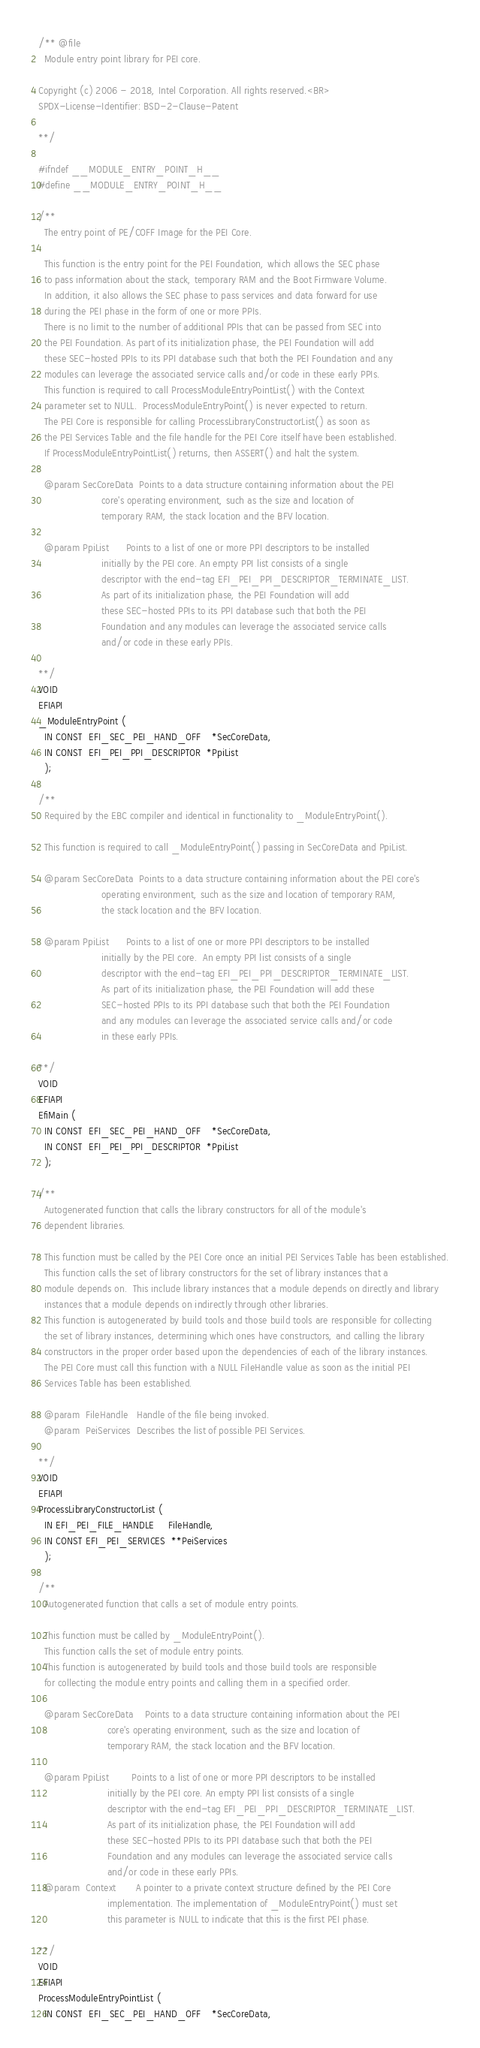<code> <loc_0><loc_0><loc_500><loc_500><_C_>/** @file
  Module entry point library for PEI core.

Copyright (c) 2006 - 2018, Intel Corporation. All rights reserved.<BR>
SPDX-License-Identifier: BSD-2-Clause-Patent

**/

#ifndef __MODULE_ENTRY_POINT_H__
#define __MODULE_ENTRY_POINT_H__

/**
  The entry point of PE/COFF Image for the PEI Core.

  This function is the entry point for the PEI Foundation, which allows the SEC phase
  to pass information about the stack, temporary RAM and the Boot Firmware Volume.
  In addition, it also allows the SEC phase to pass services and data forward for use
  during the PEI phase in the form of one or more PPIs.
  There is no limit to the number of additional PPIs that can be passed from SEC into
  the PEI Foundation. As part of its initialization phase, the PEI Foundation will add
  these SEC-hosted PPIs to its PPI database such that both the PEI Foundation and any
  modules can leverage the associated service calls and/or code in these early PPIs.
  This function is required to call ProcessModuleEntryPointList() with the Context
  parameter set to NULL.  ProcessModuleEntryPoint() is never expected to return.
  The PEI Core is responsible for calling ProcessLibraryConstructorList() as soon as
  the PEI Services Table and the file handle for the PEI Core itself have been established.
  If ProcessModuleEntryPointList() returns, then ASSERT() and halt the system.

  @param SecCoreData  Points to a data structure containing information about the PEI
                      core's operating environment, such as the size and location of
                      temporary RAM, the stack location and the BFV location.

  @param PpiList      Points to a list of one or more PPI descriptors to be installed
                      initially by the PEI core. An empty PPI list consists of a single
                      descriptor with the end-tag EFI_PEI_PPI_DESCRIPTOR_TERMINATE_LIST.
                      As part of its initialization phase, the PEI Foundation will add
                      these SEC-hosted PPIs to its PPI database such that both the PEI
                      Foundation and any modules can leverage the associated service calls
                      and/or code in these early PPIs.

**/
VOID
EFIAPI
_ModuleEntryPoint (
  IN CONST  EFI_SEC_PEI_HAND_OFF    *SecCoreData,
  IN CONST  EFI_PEI_PPI_DESCRIPTOR  *PpiList
  );

/**
  Required by the EBC compiler and identical in functionality to _ModuleEntryPoint().

  This function is required to call _ModuleEntryPoint() passing in SecCoreData and PpiList.

  @param SecCoreData  Points to a data structure containing information about the PEI core's
                      operating environment, such as the size and location of temporary RAM,
                      the stack location and the BFV location.

  @param PpiList      Points to a list of one or more PPI descriptors to be installed
                      initially by the PEI core.  An empty PPI list consists of a single
                      descriptor with the end-tag EFI_PEI_PPI_DESCRIPTOR_TERMINATE_LIST.
                      As part of its initialization phase, the PEI Foundation will add these
                      SEC-hosted PPIs to its PPI database such that both the PEI Foundation
                      and any modules can leverage the associated service calls and/or code
                      in these early PPIs.

**/
VOID
EFIAPI
EfiMain (
  IN CONST  EFI_SEC_PEI_HAND_OFF    *SecCoreData,
  IN CONST  EFI_PEI_PPI_DESCRIPTOR  *PpiList
  );

/**
  Autogenerated function that calls the library constructors for all of the module's
  dependent libraries.

  This function must be called by the PEI Core once an initial PEI Services Table has been established.
  This function calls the set of library constructors for the set of library instances that a
  module depends on.  This include library instances that a module depends on directly and library
  instances that a module depends on indirectly through other libraries.
  This function is autogenerated by build tools and those build tools are responsible for collecting
  the set of library instances, determining which ones have constructors, and calling the library
  constructors in the proper order based upon the dependencies of each of the library instances.
  The PEI Core must call this function with a NULL FileHandle value as soon as the initial PEI
  Services Table has been established.

  @param  FileHandle   Handle of the file being invoked.
  @param  PeiServices  Describes the list of possible PEI Services.

**/
VOID
EFIAPI
ProcessLibraryConstructorList (
  IN EFI_PEI_FILE_HANDLE     FileHandle,
  IN CONST EFI_PEI_SERVICES  **PeiServices
  );

/**
  Autogenerated function that calls a set of module entry points.

  This function must be called by _ModuleEntryPoint().
  This function calls the set of module entry points.
  This function is autogenerated by build tools and those build tools are responsible
  for collecting the module entry points and calling them in a specified order.

  @param SecCoreData    Points to a data structure containing information about the PEI
                        core's operating environment, such as the size and location of
                        temporary RAM, the stack location and the BFV location.

  @param PpiList        Points to a list of one or more PPI descriptors to be installed
                        initially by the PEI core. An empty PPI list consists of a single
                        descriptor with the end-tag EFI_PEI_PPI_DESCRIPTOR_TERMINATE_LIST.
                        As part of its initialization phase, the PEI Foundation will add
                        these SEC-hosted PPIs to its PPI database such that both the PEI
                        Foundation and any modules can leverage the associated service calls
                        and/or code in these early PPIs.
  @param  Context       A pointer to a private context structure defined by the PEI Core
                        implementation. The implementation of _ModuleEntryPoint() must set
                        this parameter is NULL to indicate that this is the first PEI phase.

**/
VOID
EFIAPI
ProcessModuleEntryPointList (
  IN CONST  EFI_SEC_PEI_HAND_OFF    *SecCoreData,</code> 